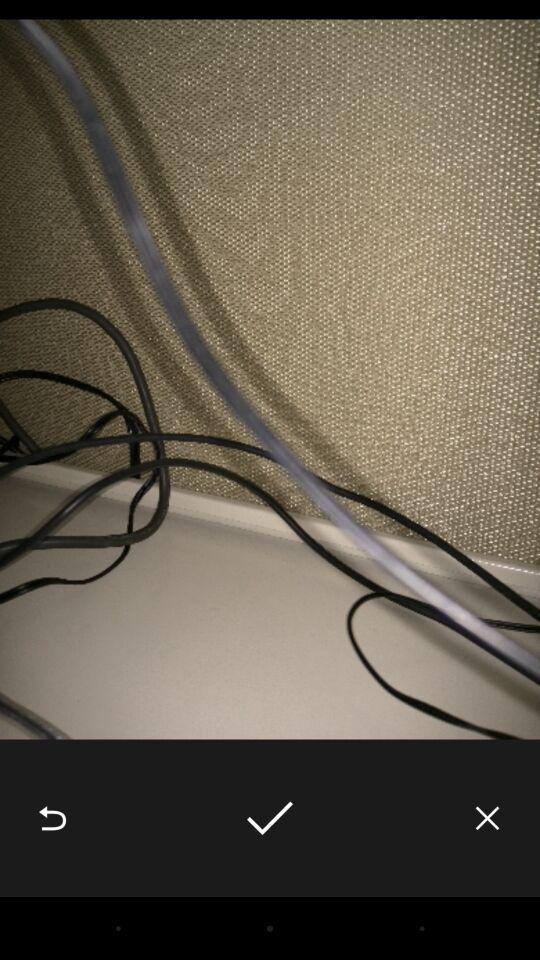Tell me what you see in this picture. Picture is displaying with different control buttons. 